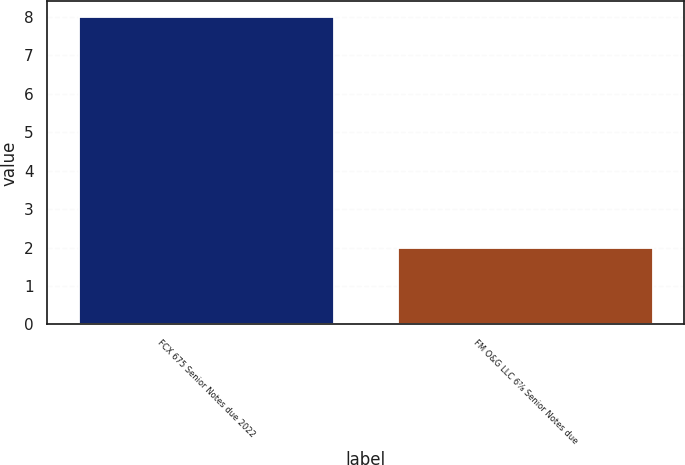<chart> <loc_0><loc_0><loc_500><loc_500><bar_chart><fcel>FCX 675 Senior Notes due 2022<fcel>FM O&G LLC 6⅞ Senior Notes due<nl><fcel>8<fcel>2<nl></chart> 